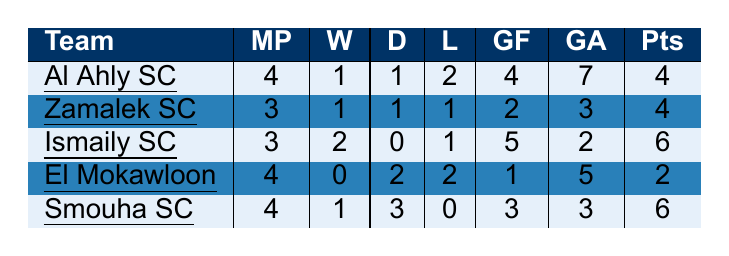What is the total number of matches played by Haras El Hodoud SC against all rival teams? By adding the "MatchesPlayed" column for all teams: 4 (Al Ahly SC) + 3 (Zamalek SC) + 3 (Ismaily SC) + 4 (El Mokawloon) + 4 (Smouha SC) = 18 matches total.
Answer: 18 Which team had the highest number of points against Haras El Hodoud SC? Comparing the "Points" column, Ismaily SC and Smouha SC both scored 6 points, which is higher than any other team listed.
Answer: Ismaily SC and Smouha SC (6 points each) Did Haras El Hodoud SC win more matches against Ismaily SC or Smouha SC? Ismaily SC has 2 wins, while Smouha SC has 1 win against Haras El Hodoud SC. Therefore, Ismaily SC had more wins.
Answer: Ismaily SC What was Haras El Hodoud SC's goal difference against Al Ahly SC? Goal difference is calculated as Goals For - Goals Against, hence 4 (GoalsFor) - 7 (GoalsAgainst) = -3.
Answer: -3 Which rival team had the lowest number of wins against Haras El Hodoud SC? By checking the "Wins" column, El Mokawloon has 0 wins, which is the lowest among all teams listed.
Answer: El Mokawloon What is the average number of draws across all teams? Adding the draws: 1 (Al Ahly SC) + 1 (Zamalek SC) + 0 (Ismaily SC) + 2 (El Mokawloon) + 3 (Smouha SC) = 7 draws. Then dividing by the number of teams (5) gives an average of 7/5 = 1.4.
Answer: 1.4 Was there any team against which Haras El Hodoud SC remained unbeaten? Checking teams with 0 losses: Smouha SC has 0 losses, and El Mokawloon has 2 losses but 2 draws, thus Smouha SC is the only unbeaten team.
Answer: Yes, Smouha SC What team's performance resulted in the highest goals scored ("GoalsFor") against Haras El Hodoud SC? Looking at the "GoalsFor" column, Ismaily SC scored 5 goals, which is higher than any other team listed.
Answer: Ismaily SC Which rival team had the second-highest number of points? After comparing the "Points" column, Al Ahly SC and Zamalek SC both have 4 points, making them the second highest after Ismaily SC and Smouha SC.
Answer: Al Ahly SC and Zamalek SC (4 points each) Calculate the total goals scored by Haras El Hodoud SC against all listed teams. Adding the "GoalsFor" column: 4 (Al Ahly SC) + 2 (Zamalek SC) + 5 (Ismaily SC) + 1 (El Mokawloon) + 3 (Smouha SC) = 15 total goals scored.
Answer: 15 